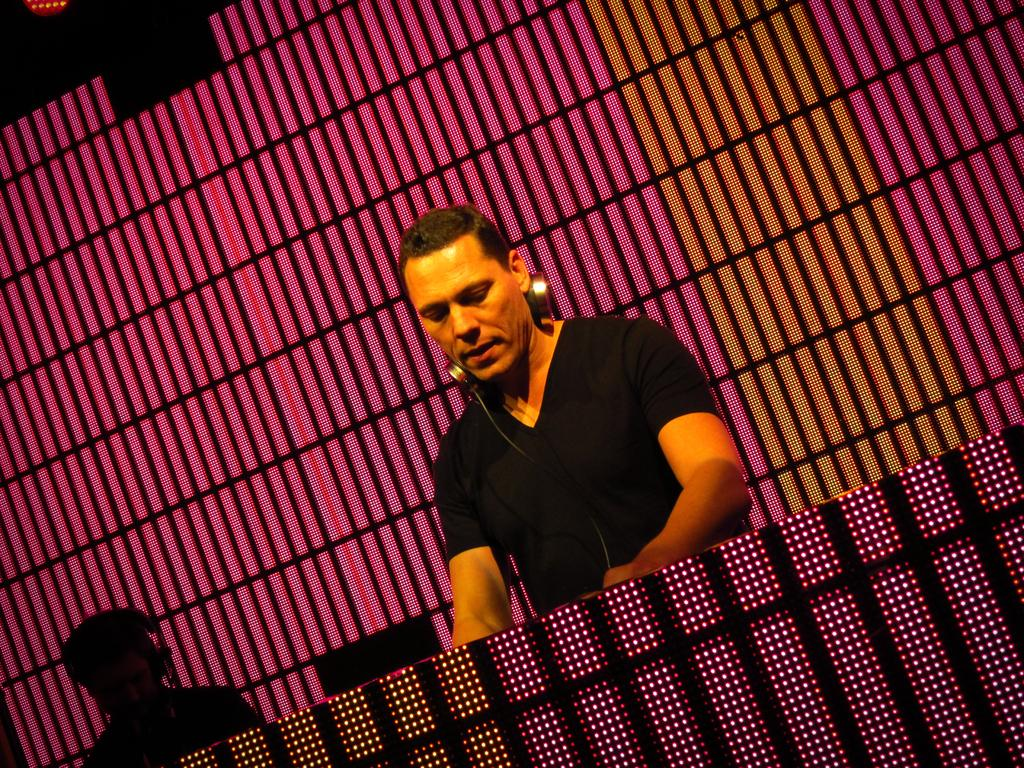How many people are in the image? There are two persons in the image. What are the persons wearing? The persons are wearing headphones. What can be seen in the background of the image? There is a chair and a screen in the background of the image. What is located in the foreground of the image? There is a table in the foreground of the image. Where is the nest located in the image? There is no nest present in the image. What type of seat is the person adjusting in the image? There is no person adjusting a seat in the image. 